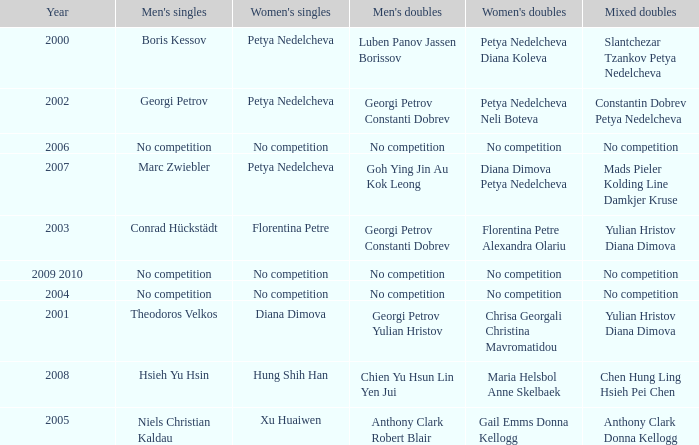What is the year when Conrad Hückstädt won Men's Single? 2003.0. 